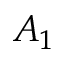Convert formula to latex. <formula><loc_0><loc_0><loc_500><loc_500>A _ { 1 }</formula> 